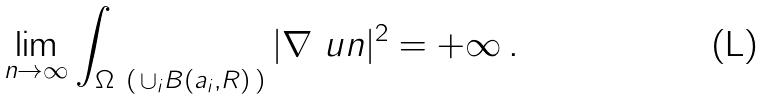Convert formula to latex. <formula><loc_0><loc_0><loc_500><loc_500>\lim _ { n \to \infty } \int _ { \Omega \ ( \, \cup _ { i } B ( a _ { i } , R ) \, ) } | \nabla \ u n | ^ { 2 } = + \infty \, .</formula> 